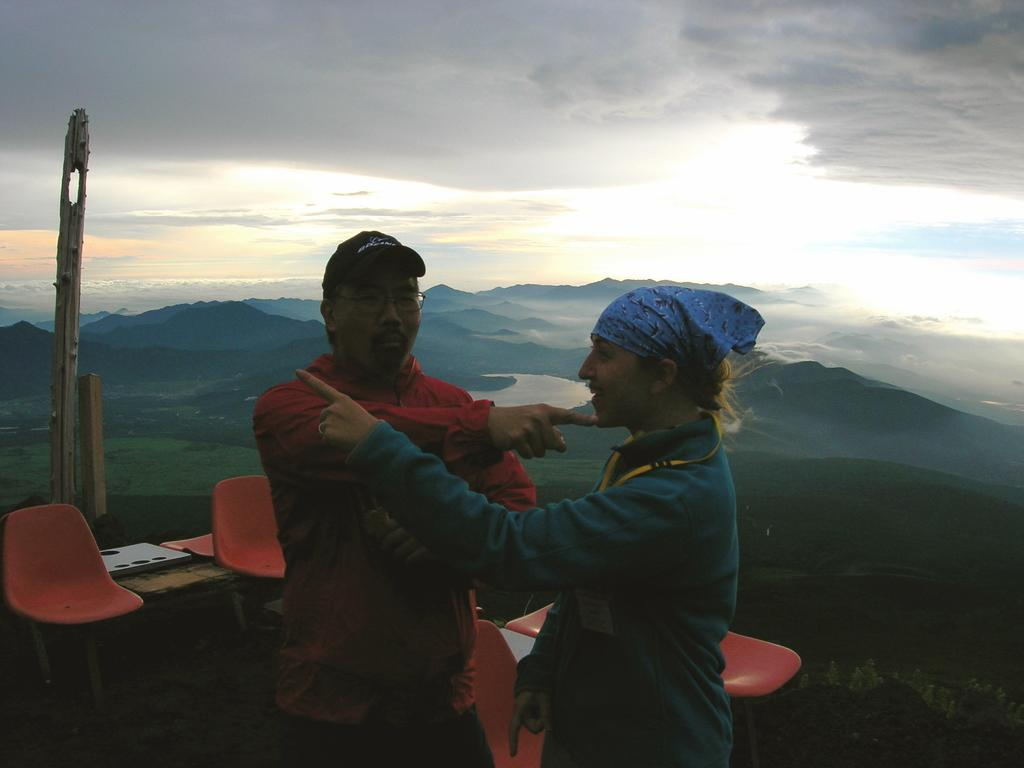How many people are in the image? There are two persons standing in the image. What are the persons doing in the image? The persons are pointing at each other. What can be seen in the background of the image? There are chairs, hills, water, and the sky visible in the background of the image. What is the condition of the sky in the image? Clouds are present in the sky. What topic are the persons discussing in the image? There is no indication of a discussion in the image, as the persons are simply pointing at each other. What type of competition is taking place between the persons in the image? There is no competition present in the image; the persons are just pointing at each other. 